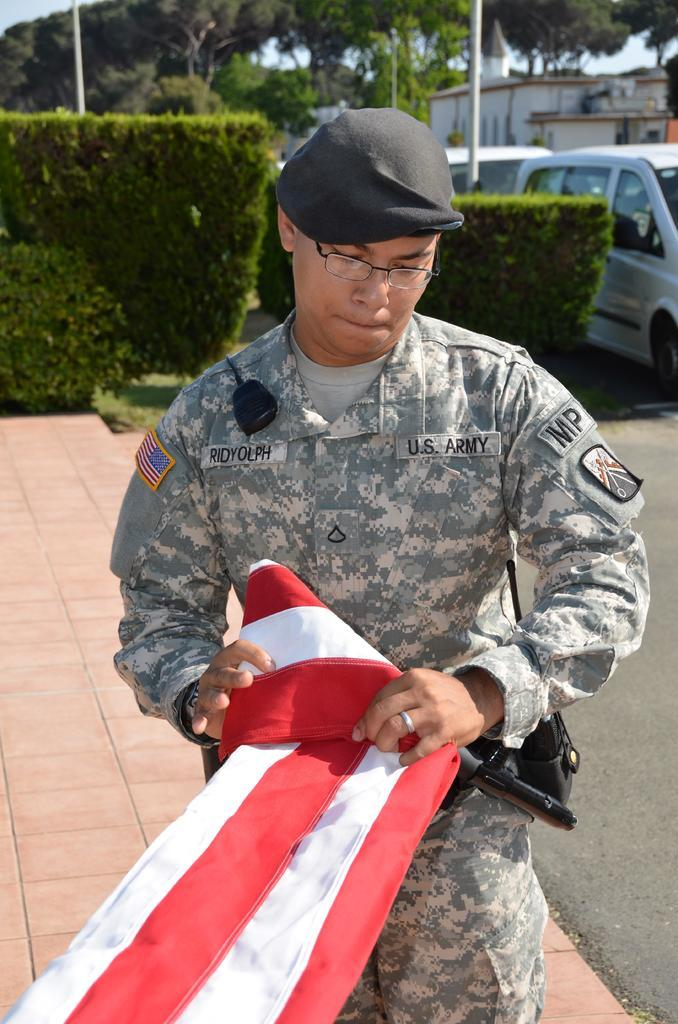What is the main subject in the center of the image? There is a person holding a flag in the center of the image. What can be seen in the background of the image? There are trees, at least one building, plants, cats, a pole, and the sky visible in the background of the image. What type of veil can be seen on the person's face in the image? There is no veil or face visible in the image; it only shows a person holding a flag. 